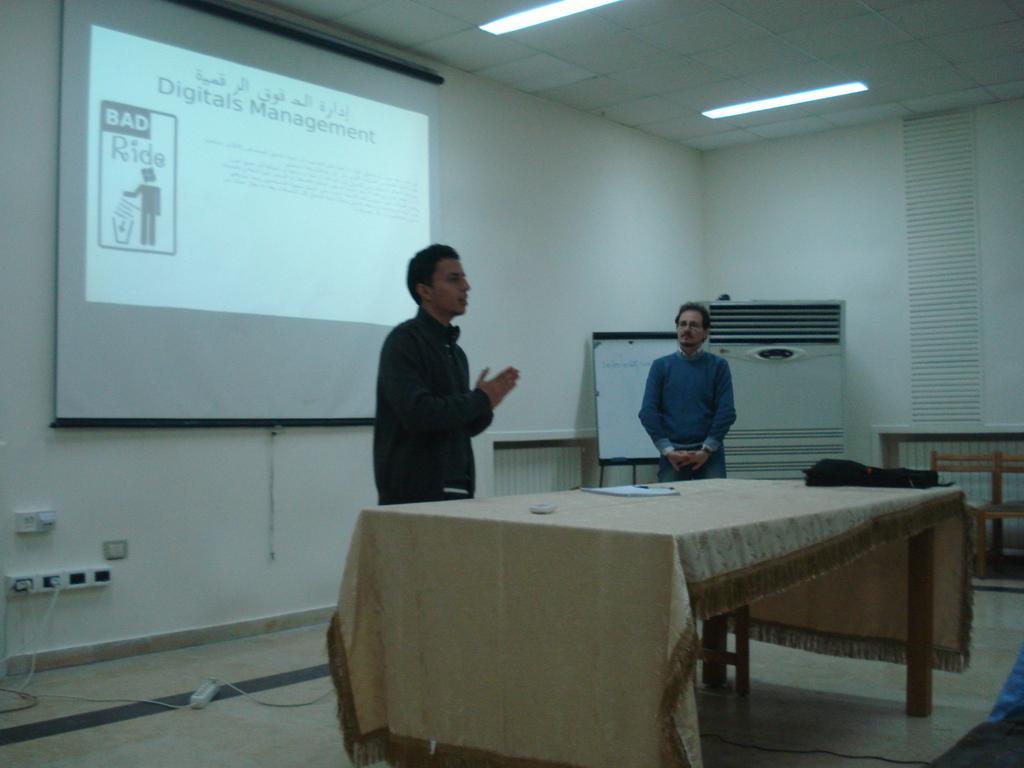Describe this image in one or two sentences. In this image there is a person with black jacket standing and talking and there is other person with blue jacket standing and listening. At the middle there is a table covered with cloth, there is a bag, paper, pen on the table. At the top there are lights and at the back there is a screen on the wall. There is a board and a cooler at the back and at the bottom there is a wire. 